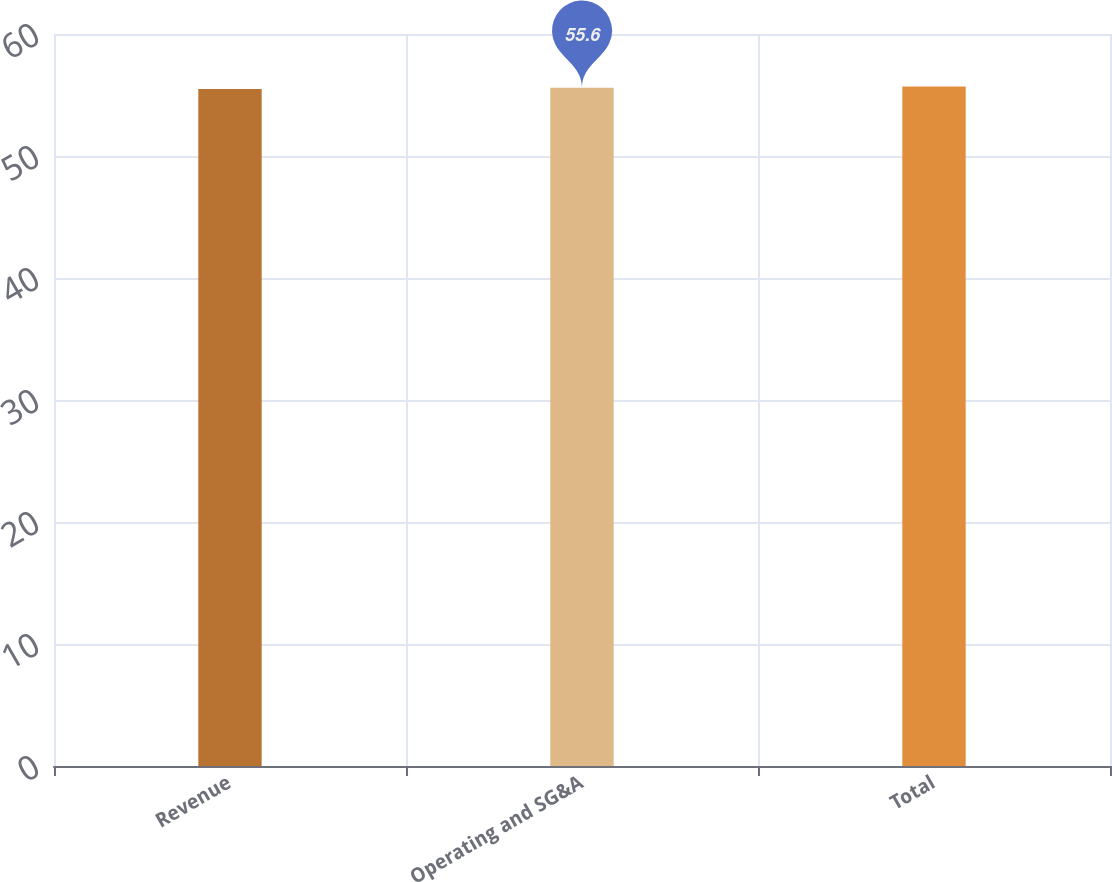Convert chart to OTSL. <chart><loc_0><loc_0><loc_500><loc_500><bar_chart><fcel>Revenue<fcel>Operating and SG&A<fcel>Total<nl><fcel>55.5<fcel>55.6<fcel>55.7<nl></chart> 